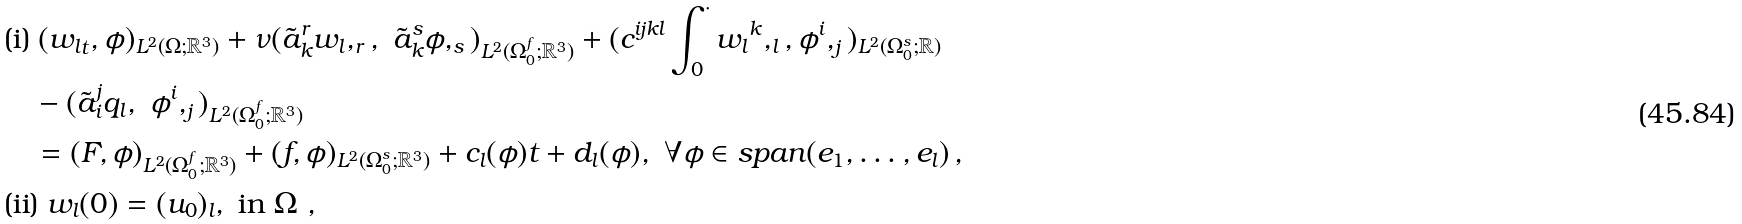Convert formula to latex. <formula><loc_0><loc_0><loc_500><loc_500>& \text {(i)} \ ( { w _ { l } } _ { t } , \phi ) _ { L ^ { 2 } ( \Omega ; { \mathbb { R } } ^ { 3 } ) } + { \nu } ( \tilde { a } _ { k } ^ { r } { w _ { l } } , _ { r } , \ \tilde { a } _ { k } ^ { s } \phi , _ { s } ) _ { L ^ { 2 } ( \Omega _ { 0 } ^ { f } ; { \mathbb { R } } ^ { 3 } ) } + ( c ^ { i j k l } \int _ { 0 } ^ { \cdot } { w _ { l } } ^ { k } , _ { l } , \phi ^ { i } , _ { j } ) _ { L ^ { 2 } ( \Omega _ { 0 } ^ { s } ; { \mathbb { R } } ) } \\ & \quad - ( \tilde { a } _ { i } ^ { j } q _ { l } , \ \phi ^ { i } , _ { j } ) _ { L ^ { 2 } ( \Omega _ { 0 } ^ { f } ; { \mathbb { R } } ^ { 3 } ) } \\ & \quad = ( F , \phi ) _ { L ^ { 2 } ( \Omega _ { 0 } ^ { f } ; { \mathbb { R } } ^ { 3 } ) } + ( f , \phi ) _ { L ^ { 2 } ( \Omega _ { 0 } ^ { s } ; { \mathbb { R } } ^ { 3 } ) } + c _ { l } ( \phi ) t + d _ { l } ( \phi ) , \ \forall \phi \in s p a n ( e _ { 1 } , \dots , e _ { l } ) \, , \\ & \text {(ii)} \ w _ { l } ( 0 ) = ( u _ { 0 } ) _ { l } , \ \text {in} \ \Omega \ ,</formula> 